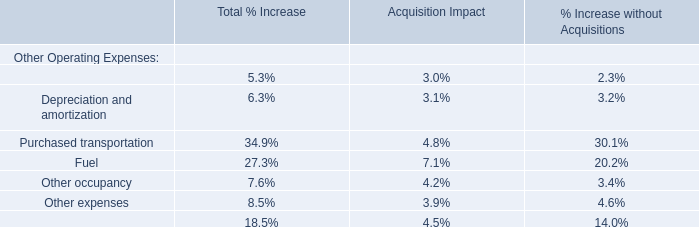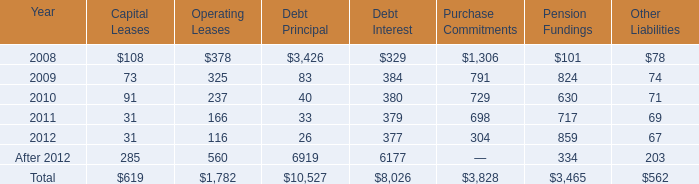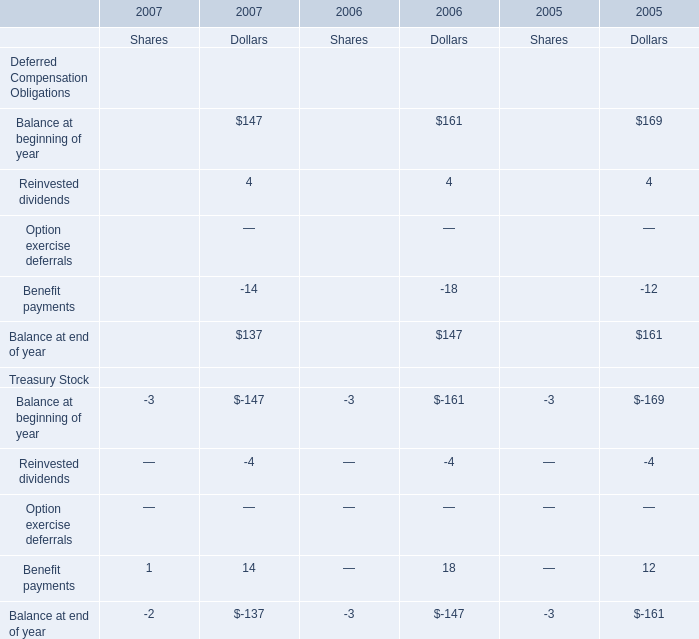What's the sum of all Balance at end of year that are positive in 2006 for dollars? 
Computations: (161 + 4)
Answer: 165.0. 